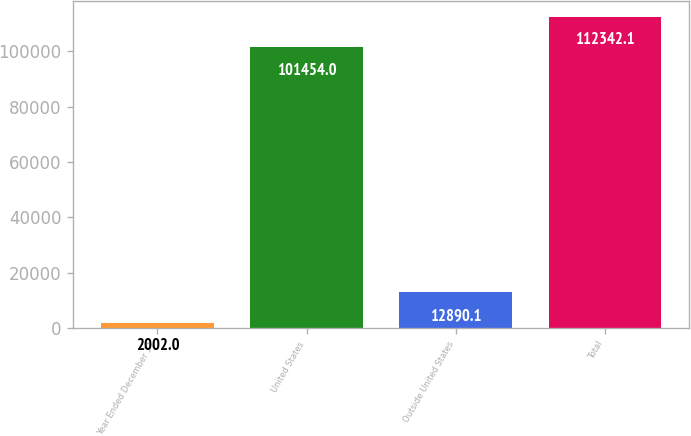Convert chart. <chart><loc_0><loc_0><loc_500><loc_500><bar_chart><fcel>Year Ended December 31<fcel>United States<fcel>Outside United States<fcel>Total<nl><fcel>2002<fcel>101454<fcel>12890.1<fcel>112342<nl></chart> 